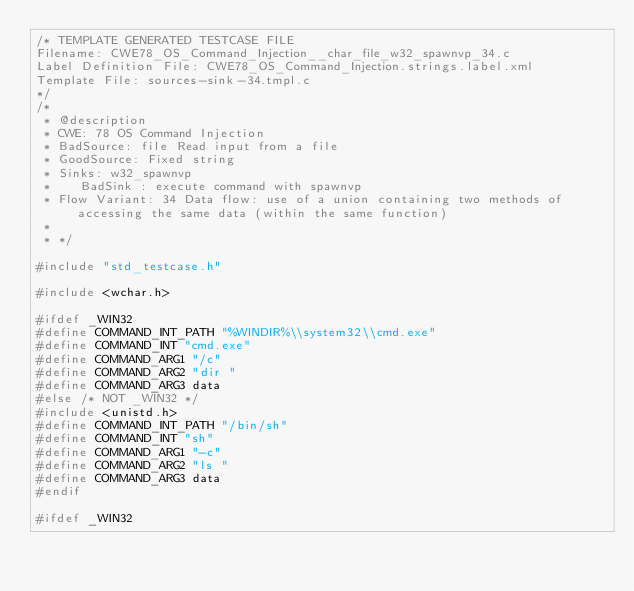<code> <loc_0><loc_0><loc_500><loc_500><_C_>/* TEMPLATE GENERATED TESTCASE FILE
Filename: CWE78_OS_Command_Injection__char_file_w32_spawnvp_34.c
Label Definition File: CWE78_OS_Command_Injection.strings.label.xml
Template File: sources-sink-34.tmpl.c
*/
/*
 * @description
 * CWE: 78 OS Command Injection
 * BadSource: file Read input from a file
 * GoodSource: Fixed string
 * Sinks: w32_spawnvp
 *    BadSink : execute command with spawnvp
 * Flow Variant: 34 Data flow: use of a union containing two methods of accessing the same data (within the same function)
 *
 * */

#include "std_testcase.h"

#include <wchar.h>

#ifdef _WIN32
#define COMMAND_INT_PATH "%WINDIR%\\system32\\cmd.exe"
#define COMMAND_INT "cmd.exe"
#define COMMAND_ARG1 "/c"
#define COMMAND_ARG2 "dir "
#define COMMAND_ARG3 data
#else /* NOT _WIN32 */
#include <unistd.h>
#define COMMAND_INT_PATH "/bin/sh"
#define COMMAND_INT "sh"
#define COMMAND_ARG1 "-c"
#define COMMAND_ARG2 "ls "
#define COMMAND_ARG3 data
#endif

#ifdef _WIN32</code> 